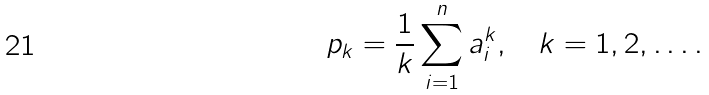Convert formula to latex. <formula><loc_0><loc_0><loc_500><loc_500>p _ { k } = \frac { 1 } { k } \sum ^ { n } _ { i = 1 } a ^ { k } _ { i } , \quad k = 1 , 2 , \dots .</formula> 